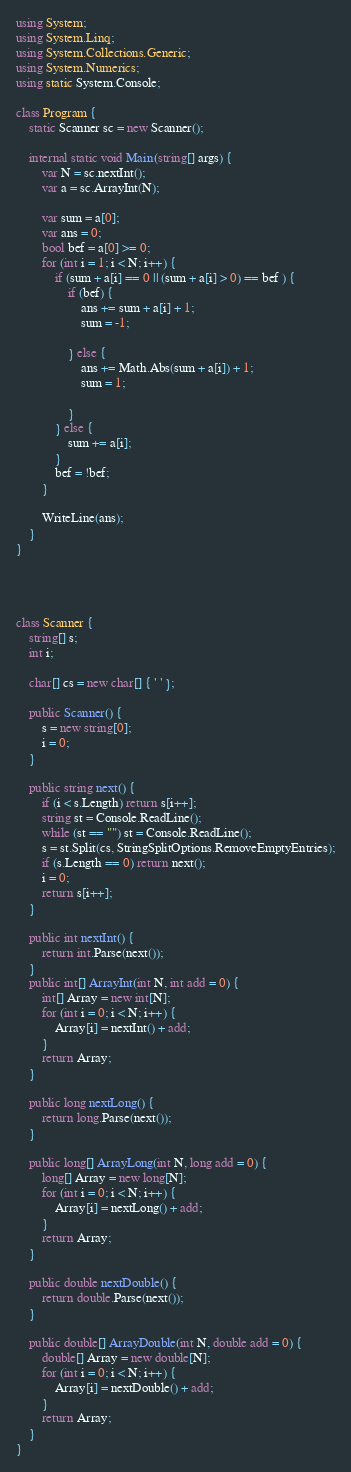Convert code to text. <code><loc_0><loc_0><loc_500><loc_500><_C#_>using System;
using System.Linq;
using System.Collections.Generic;
using System.Numerics;
using static System.Console;

class Program {
    static Scanner sc = new Scanner();

    internal static void Main(string[] args) {
        var N = sc.nextInt();
        var a = sc.ArrayInt(N);

        var sum = a[0];
        var ans = 0;
        bool bef = a[0] >= 0;
        for (int i = 1; i < N; i++) {
            if (sum + a[i] == 0 || (sum + a[i] > 0) == bef ) {
                if (bef) {
                    ans += sum + a[i] + 1;
                    sum = -1;

                } else {
                    ans += Math.Abs(sum + a[i]) + 1;
                    sum = 1;

                }
            } else {
                sum += a[i];
            }
            bef = !bef;
        }

        WriteLine(ans);
    }
}




class Scanner {
    string[] s;
    int i;

    char[] cs = new char[] { ' ' };

    public Scanner() {
        s = new string[0];
        i = 0;
    }

    public string next() {
        if (i < s.Length) return s[i++];
        string st = Console.ReadLine();
        while (st == "") st = Console.ReadLine();
        s = st.Split(cs, StringSplitOptions.RemoveEmptyEntries);
        if (s.Length == 0) return next();
        i = 0;
        return s[i++];
    }

    public int nextInt() {
        return int.Parse(next());
    }
    public int[] ArrayInt(int N, int add = 0) {
        int[] Array = new int[N];
        for (int i = 0; i < N; i++) {
            Array[i] = nextInt() + add;
        }
        return Array;
    }

    public long nextLong() {
        return long.Parse(next());
    }

    public long[] ArrayLong(int N, long add = 0) {
        long[] Array = new long[N];
        for (int i = 0; i < N; i++) {
            Array[i] = nextLong() + add;
        }
        return Array;
    }

    public double nextDouble() {
        return double.Parse(next());
    }

    public double[] ArrayDouble(int N, double add = 0) {
        double[] Array = new double[N];
        for (int i = 0; i < N; i++) {
            Array[i] = nextDouble() + add;
        }
        return Array;
    }
}</code> 